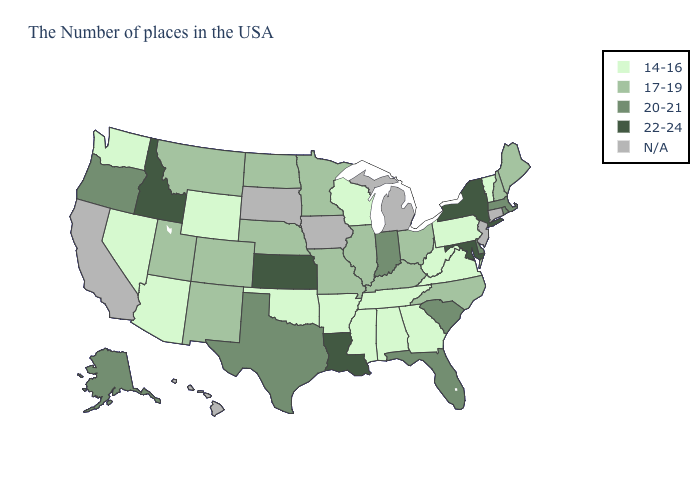Among the states that border Connecticut , which have the lowest value?
Give a very brief answer. Massachusetts, Rhode Island. What is the value of West Virginia?
Short answer required. 14-16. Is the legend a continuous bar?
Short answer required. No. What is the lowest value in states that border Maryland?
Keep it brief. 14-16. What is the value of South Dakota?
Short answer required. N/A. What is the value of Virginia?
Write a very short answer. 14-16. Name the states that have a value in the range 20-21?
Give a very brief answer. Massachusetts, Rhode Island, Delaware, South Carolina, Florida, Indiana, Texas, Oregon, Alaska. What is the value of North Dakota?
Answer briefly. 17-19. Name the states that have a value in the range 20-21?
Answer briefly. Massachusetts, Rhode Island, Delaware, South Carolina, Florida, Indiana, Texas, Oregon, Alaska. What is the lowest value in states that border Indiana?
Answer briefly. 17-19. Name the states that have a value in the range 17-19?
Keep it brief. Maine, New Hampshire, North Carolina, Ohio, Kentucky, Illinois, Missouri, Minnesota, Nebraska, North Dakota, Colorado, New Mexico, Utah, Montana. Does Texas have the lowest value in the USA?
Write a very short answer. No. What is the lowest value in the USA?
Write a very short answer. 14-16. Name the states that have a value in the range 17-19?
Give a very brief answer. Maine, New Hampshire, North Carolina, Ohio, Kentucky, Illinois, Missouri, Minnesota, Nebraska, North Dakota, Colorado, New Mexico, Utah, Montana. 